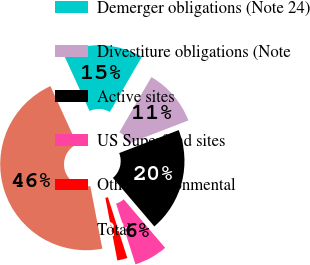<chart> <loc_0><loc_0><loc_500><loc_500><pie_chart><fcel>Demerger obligations (Note 24)<fcel>Divestiture obligations (Note<fcel>Active sites<fcel>US Superfund sites<fcel>Other environmental<fcel>Total<nl><fcel>15.19%<fcel>10.76%<fcel>19.62%<fcel>6.33%<fcel>1.9%<fcel>46.19%<nl></chart> 